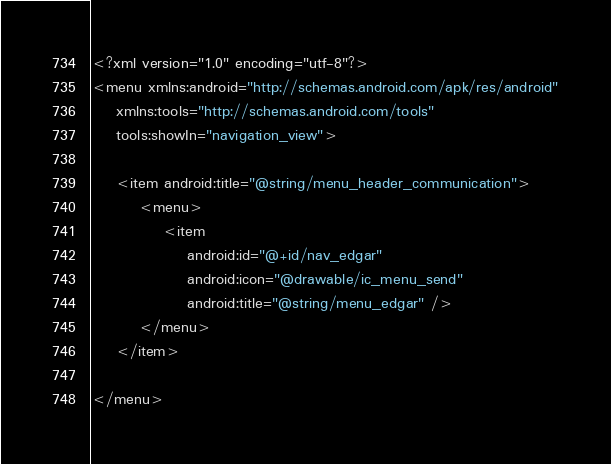<code> <loc_0><loc_0><loc_500><loc_500><_XML_><?xml version="1.0" encoding="utf-8"?>
<menu xmlns:android="http://schemas.android.com/apk/res/android"
    xmlns:tools="http://schemas.android.com/tools"
    tools:showIn="navigation_view">

    <item android:title="@string/menu_header_communication">
        <menu>
            <item
                android:id="@+id/nav_edgar"
                android:icon="@drawable/ic_menu_send"
                android:title="@string/menu_edgar" />
        </menu>
    </item>

</menu>
</code> 